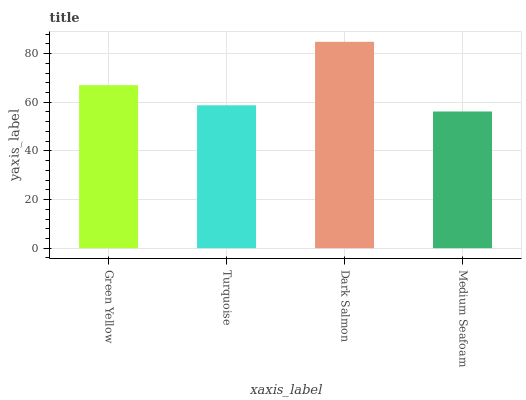Is Medium Seafoam the minimum?
Answer yes or no. Yes. Is Dark Salmon the maximum?
Answer yes or no. Yes. Is Turquoise the minimum?
Answer yes or no. No. Is Turquoise the maximum?
Answer yes or no. No. Is Green Yellow greater than Turquoise?
Answer yes or no. Yes. Is Turquoise less than Green Yellow?
Answer yes or no. Yes. Is Turquoise greater than Green Yellow?
Answer yes or no. No. Is Green Yellow less than Turquoise?
Answer yes or no. No. Is Green Yellow the high median?
Answer yes or no. Yes. Is Turquoise the low median?
Answer yes or no. Yes. Is Turquoise the high median?
Answer yes or no. No. Is Dark Salmon the low median?
Answer yes or no. No. 